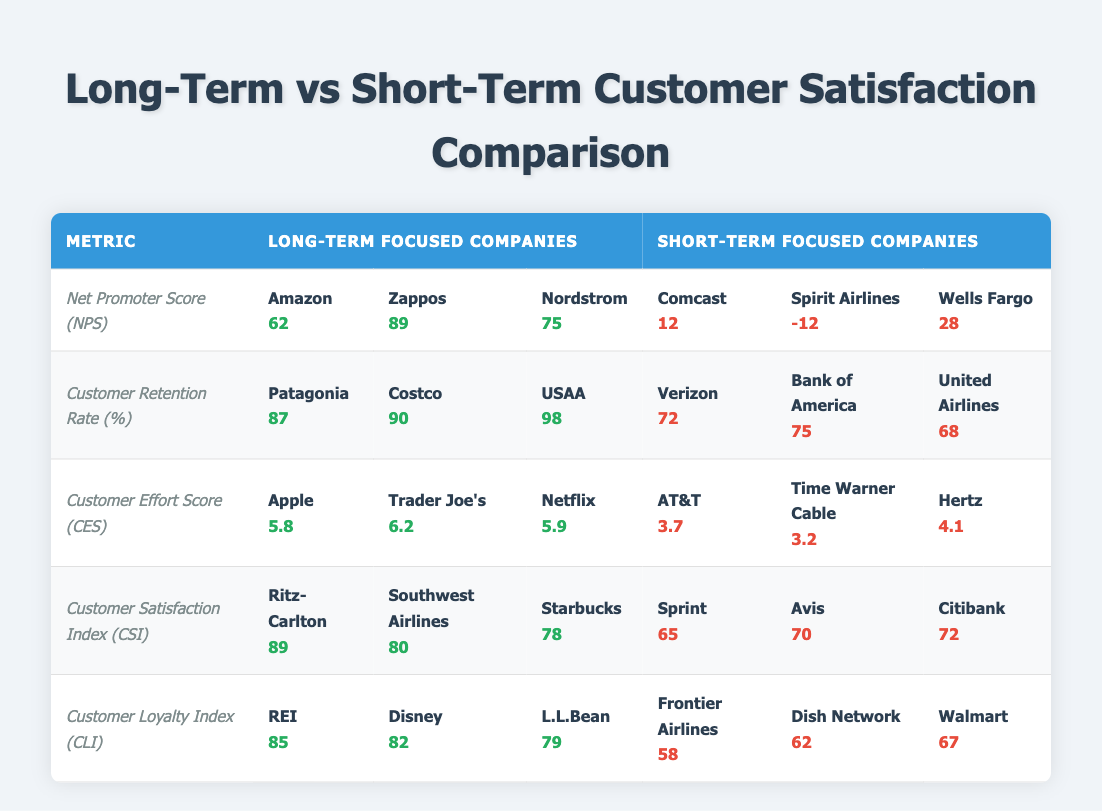What is the Net Promoter Score for Zappos? The table lists Zappos' Net Promoter Score under the "Long-Term Focused Companies" section, showing a score of 89.
Answer: 89 Which company has the highest Customer Retention Rate? The highest Customer Retention Rate is found by looking through the "Long-Term Focused Companies" section, where USAA shows a score of 98, the highest among all companies listed.
Answer: 98 Is the Customer Satisfaction Index for Starbucks higher than that of Citibank? Starbucks has a Customer Satisfaction Index of 78 while Citibank has a score of 72. Since 78 is greater than 72, the answer is yes.
Answer: Yes What is the average Customer Effort Score for long-term focused companies? To calculate the average, sum the long-term scores: (5.8 + 6.2 + 5.9) = 17.9. There are three companies, so we divide: 17.9 / 3 = 5.97.
Answer: 5.97 Which short-term focused company has the lowest Net Promoter Score? The Net Promoter Scores for the short-term focused companies are listed as follows: Comcast (12), Spirit Airlines (-12), and Wells Fargo (28). Spirit Airlines has the lowest at -12.
Answer: Spirit Airlines What is the difference in Customer Loyalty Index between REI and Walmart? For the Customer Loyalty Index, REI is scored at 85 while Walmart has a score of 67. To find the difference: 85 - 67 = 18.
Answer: 18 Are all the companies in the long-term focused category achieving a Customer Satisfaction Index above 75? The long-term focused companies show scores of Ritz-Carlton (89), Southwest Airlines (80), and Starbucks (78), all of which exceed 75. Therefore, the answer is yes.
Answer: Yes Which short-term company has a score closest to the average Net Promoter Score of long-term focused companies? First, calculate the average NPS for long-term focused companies: (62 + 89 + 75) / 3 = 75.33. Then, comparing short-term scores - Comcast (12), Spirit Airlines (-12), Wells Fargo (28), Wells Fargo's score of 28 is closest.
Answer: Wells Fargo What is the sum of the Customer Retention Rates for the three long-term focused companies? Summing the Customer Retention Rates: 87 (Patagonia) + 90 (Costco) + 98 (USAA) = 275.
Answer: 275 